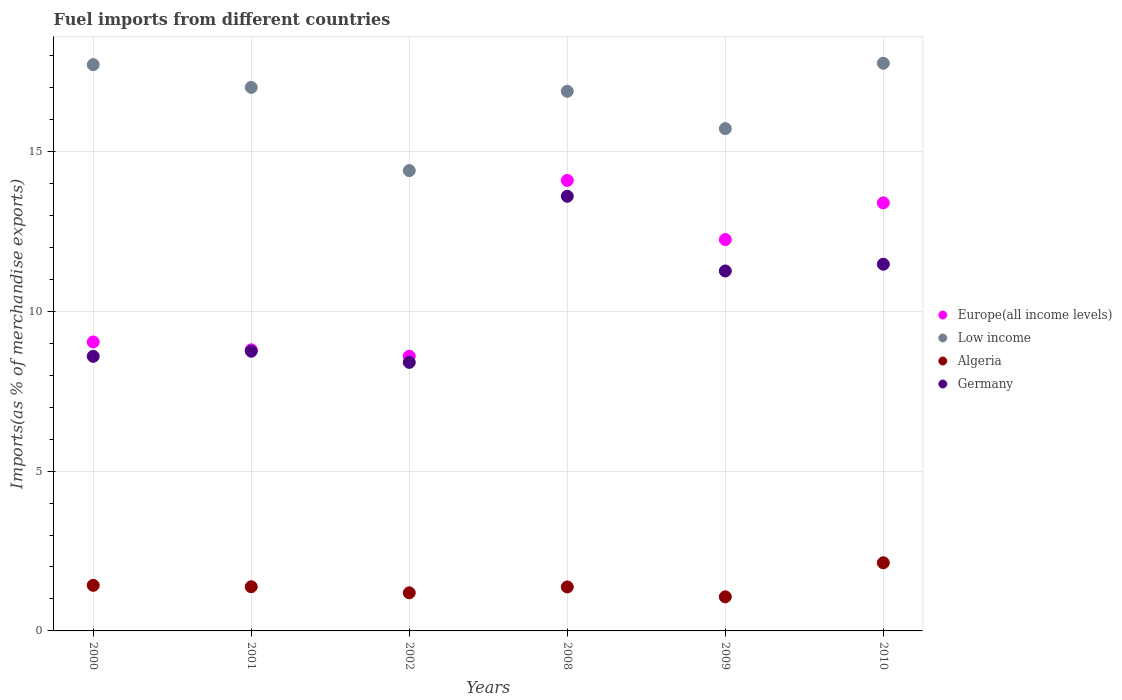Is the number of dotlines equal to the number of legend labels?
Your answer should be very brief. Yes. What is the percentage of imports to different countries in Germany in 2000?
Offer a very short reply. 8.59. Across all years, what is the maximum percentage of imports to different countries in Algeria?
Offer a very short reply. 2.13. Across all years, what is the minimum percentage of imports to different countries in Europe(all income levels)?
Give a very brief answer. 8.59. In which year was the percentage of imports to different countries in Germany minimum?
Offer a very short reply. 2002. What is the total percentage of imports to different countries in Algeria in the graph?
Provide a short and direct response. 8.58. What is the difference between the percentage of imports to different countries in Europe(all income levels) in 2008 and that in 2009?
Offer a terse response. 1.85. What is the difference between the percentage of imports to different countries in Low income in 2002 and the percentage of imports to different countries in Europe(all income levels) in 2009?
Give a very brief answer. 2.16. What is the average percentage of imports to different countries in Germany per year?
Ensure brevity in your answer.  10.35. In the year 2002, what is the difference between the percentage of imports to different countries in Algeria and percentage of imports to different countries in Low income?
Provide a succinct answer. -13.21. What is the ratio of the percentage of imports to different countries in Europe(all income levels) in 2009 to that in 2010?
Offer a very short reply. 0.91. What is the difference between the highest and the second highest percentage of imports to different countries in Low income?
Offer a terse response. 0.04. What is the difference between the highest and the lowest percentage of imports to different countries in Low income?
Make the answer very short. 3.36. In how many years, is the percentage of imports to different countries in Germany greater than the average percentage of imports to different countries in Germany taken over all years?
Provide a succinct answer. 3. Is it the case that in every year, the sum of the percentage of imports to different countries in Germany and percentage of imports to different countries in Algeria  is greater than the sum of percentage of imports to different countries in Low income and percentage of imports to different countries in Europe(all income levels)?
Ensure brevity in your answer.  No. Does the percentage of imports to different countries in Germany monotonically increase over the years?
Provide a short and direct response. No. Is the percentage of imports to different countries in Europe(all income levels) strictly less than the percentage of imports to different countries in Algeria over the years?
Your response must be concise. No. How many dotlines are there?
Keep it short and to the point. 4. What is the difference between two consecutive major ticks on the Y-axis?
Your answer should be compact. 5. Are the values on the major ticks of Y-axis written in scientific E-notation?
Your answer should be compact. No. Does the graph contain grids?
Keep it short and to the point. Yes. How many legend labels are there?
Keep it short and to the point. 4. How are the legend labels stacked?
Provide a short and direct response. Vertical. What is the title of the graph?
Keep it short and to the point. Fuel imports from different countries. What is the label or title of the Y-axis?
Make the answer very short. Imports(as % of merchandise exports). What is the Imports(as % of merchandise exports) of Europe(all income levels) in 2000?
Offer a terse response. 9.04. What is the Imports(as % of merchandise exports) of Low income in 2000?
Your answer should be very brief. 17.72. What is the Imports(as % of merchandise exports) of Algeria in 2000?
Keep it short and to the point. 1.43. What is the Imports(as % of merchandise exports) in Germany in 2000?
Your answer should be very brief. 8.59. What is the Imports(as % of merchandise exports) of Europe(all income levels) in 2001?
Your answer should be very brief. 8.8. What is the Imports(as % of merchandise exports) of Low income in 2001?
Your answer should be compact. 17.01. What is the Imports(as % of merchandise exports) of Algeria in 2001?
Ensure brevity in your answer.  1.38. What is the Imports(as % of merchandise exports) in Germany in 2001?
Make the answer very short. 8.75. What is the Imports(as % of merchandise exports) in Europe(all income levels) in 2002?
Provide a short and direct response. 8.59. What is the Imports(as % of merchandise exports) in Low income in 2002?
Give a very brief answer. 14.4. What is the Imports(as % of merchandise exports) in Algeria in 2002?
Your answer should be compact. 1.19. What is the Imports(as % of merchandise exports) of Germany in 2002?
Provide a succinct answer. 8.4. What is the Imports(as % of merchandise exports) in Europe(all income levels) in 2008?
Offer a very short reply. 14.09. What is the Imports(as % of merchandise exports) in Low income in 2008?
Keep it short and to the point. 16.88. What is the Imports(as % of merchandise exports) of Algeria in 2008?
Offer a very short reply. 1.38. What is the Imports(as % of merchandise exports) of Germany in 2008?
Give a very brief answer. 13.6. What is the Imports(as % of merchandise exports) in Europe(all income levels) in 2009?
Give a very brief answer. 12.24. What is the Imports(as % of merchandise exports) in Low income in 2009?
Offer a very short reply. 15.72. What is the Imports(as % of merchandise exports) of Algeria in 2009?
Your answer should be very brief. 1.07. What is the Imports(as % of merchandise exports) of Germany in 2009?
Provide a short and direct response. 11.26. What is the Imports(as % of merchandise exports) of Europe(all income levels) in 2010?
Give a very brief answer. 13.39. What is the Imports(as % of merchandise exports) of Low income in 2010?
Ensure brevity in your answer.  17.76. What is the Imports(as % of merchandise exports) of Algeria in 2010?
Your answer should be very brief. 2.13. What is the Imports(as % of merchandise exports) of Germany in 2010?
Give a very brief answer. 11.47. Across all years, what is the maximum Imports(as % of merchandise exports) of Europe(all income levels)?
Your response must be concise. 14.09. Across all years, what is the maximum Imports(as % of merchandise exports) of Low income?
Give a very brief answer. 17.76. Across all years, what is the maximum Imports(as % of merchandise exports) in Algeria?
Keep it short and to the point. 2.13. Across all years, what is the maximum Imports(as % of merchandise exports) of Germany?
Offer a very short reply. 13.6. Across all years, what is the minimum Imports(as % of merchandise exports) in Europe(all income levels)?
Your answer should be very brief. 8.59. Across all years, what is the minimum Imports(as % of merchandise exports) in Low income?
Ensure brevity in your answer.  14.4. Across all years, what is the minimum Imports(as % of merchandise exports) in Algeria?
Offer a very short reply. 1.07. Across all years, what is the minimum Imports(as % of merchandise exports) of Germany?
Make the answer very short. 8.4. What is the total Imports(as % of merchandise exports) in Europe(all income levels) in the graph?
Your answer should be compact. 66.16. What is the total Imports(as % of merchandise exports) of Low income in the graph?
Keep it short and to the point. 99.48. What is the total Imports(as % of merchandise exports) of Algeria in the graph?
Give a very brief answer. 8.58. What is the total Imports(as % of merchandise exports) of Germany in the graph?
Give a very brief answer. 62.08. What is the difference between the Imports(as % of merchandise exports) of Europe(all income levels) in 2000 and that in 2001?
Provide a short and direct response. 0.24. What is the difference between the Imports(as % of merchandise exports) of Low income in 2000 and that in 2001?
Give a very brief answer. 0.71. What is the difference between the Imports(as % of merchandise exports) of Algeria in 2000 and that in 2001?
Keep it short and to the point. 0.04. What is the difference between the Imports(as % of merchandise exports) in Germany in 2000 and that in 2001?
Offer a very short reply. -0.16. What is the difference between the Imports(as % of merchandise exports) of Europe(all income levels) in 2000 and that in 2002?
Give a very brief answer. 0.45. What is the difference between the Imports(as % of merchandise exports) of Low income in 2000 and that in 2002?
Offer a terse response. 3.31. What is the difference between the Imports(as % of merchandise exports) of Algeria in 2000 and that in 2002?
Offer a terse response. 0.23. What is the difference between the Imports(as % of merchandise exports) in Germany in 2000 and that in 2002?
Provide a succinct answer. 0.19. What is the difference between the Imports(as % of merchandise exports) of Europe(all income levels) in 2000 and that in 2008?
Keep it short and to the point. -5.05. What is the difference between the Imports(as % of merchandise exports) in Algeria in 2000 and that in 2008?
Make the answer very short. 0.05. What is the difference between the Imports(as % of merchandise exports) of Germany in 2000 and that in 2008?
Offer a terse response. -5.01. What is the difference between the Imports(as % of merchandise exports) of Europe(all income levels) in 2000 and that in 2009?
Make the answer very short. -3.2. What is the difference between the Imports(as % of merchandise exports) of Low income in 2000 and that in 2009?
Your answer should be compact. 2. What is the difference between the Imports(as % of merchandise exports) in Algeria in 2000 and that in 2009?
Provide a short and direct response. 0.36. What is the difference between the Imports(as % of merchandise exports) in Germany in 2000 and that in 2009?
Your answer should be compact. -2.67. What is the difference between the Imports(as % of merchandise exports) of Europe(all income levels) in 2000 and that in 2010?
Your answer should be very brief. -4.35. What is the difference between the Imports(as % of merchandise exports) of Low income in 2000 and that in 2010?
Provide a succinct answer. -0.04. What is the difference between the Imports(as % of merchandise exports) in Algeria in 2000 and that in 2010?
Give a very brief answer. -0.71. What is the difference between the Imports(as % of merchandise exports) in Germany in 2000 and that in 2010?
Make the answer very short. -2.88. What is the difference between the Imports(as % of merchandise exports) in Europe(all income levels) in 2001 and that in 2002?
Offer a very short reply. 0.2. What is the difference between the Imports(as % of merchandise exports) in Low income in 2001 and that in 2002?
Offer a very short reply. 2.6. What is the difference between the Imports(as % of merchandise exports) of Algeria in 2001 and that in 2002?
Offer a very short reply. 0.19. What is the difference between the Imports(as % of merchandise exports) in Germany in 2001 and that in 2002?
Give a very brief answer. 0.35. What is the difference between the Imports(as % of merchandise exports) of Europe(all income levels) in 2001 and that in 2008?
Provide a short and direct response. -5.3. What is the difference between the Imports(as % of merchandise exports) in Low income in 2001 and that in 2008?
Provide a short and direct response. 0.12. What is the difference between the Imports(as % of merchandise exports) in Algeria in 2001 and that in 2008?
Your answer should be very brief. 0.01. What is the difference between the Imports(as % of merchandise exports) of Germany in 2001 and that in 2008?
Provide a short and direct response. -4.85. What is the difference between the Imports(as % of merchandise exports) of Europe(all income levels) in 2001 and that in 2009?
Provide a short and direct response. -3.45. What is the difference between the Imports(as % of merchandise exports) in Low income in 2001 and that in 2009?
Give a very brief answer. 1.29. What is the difference between the Imports(as % of merchandise exports) of Algeria in 2001 and that in 2009?
Provide a succinct answer. 0.32. What is the difference between the Imports(as % of merchandise exports) in Germany in 2001 and that in 2009?
Offer a terse response. -2.51. What is the difference between the Imports(as % of merchandise exports) in Europe(all income levels) in 2001 and that in 2010?
Ensure brevity in your answer.  -4.6. What is the difference between the Imports(as % of merchandise exports) in Low income in 2001 and that in 2010?
Provide a short and direct response. -0.75. What is the difference between the Imports(as % of merchandise exports) in Algeria in 2001 and that in 2010?
Ensure brevity in your answer.  -0.75. What is the difference between the Imports(as % of merchandise exports) in Germany in 2001 and that in 2010?
Your answer should be compact. -2.72. What is the difference between the Imports(as % of merchandise exports) in Europe(all income levels) in 2002 and that in 2008?
Keep it short and to the point. -5.5. What is the difference between the Imports(as % of merchandise exports) in Low income in 2002 and that in 2008?
Ensure brevity in your answer.  -2.48. What is the difference between the Imports(as % of merchandise exports) of Algeria in 2002 and that in 2008?
Provide a succinct answer. -0.18. What is the difference between the Imports(as % of merchandise exports) of Germany in 2002 and that in 2008?
Provide a succinct answer. -5.2. What is the difference between the Imports(as % of merchandise exports) in Europe(all income levels) in 2002 and that in 2009?
Your answer should be very brief. -3.65. What is the difference between the Imports(as % of merchandise exports) of Low income in 2002 and that in 2009?
Give a very brief answer. -1.31. What is the difference between the Imports(as % of merchandise exports) in Algeria in 2002 and that in 2009?
Your response must be concise. 0.12. What is the difference between the Imports(as % of merchandise exports) in Germany in 2002 and that in 2009?
Ensure brevity in your answer.  -2.86. What is the difference between the Imports(as % of merchandise exports) in Europe(all income levels) in 2002 and that in 2010?
Provide a short and direct response. -4.8. What is the difference between the Imports(as % of merchandise exports) in Low income in 2002 and that in 2010?
Provide a short and direct response. -3.36. What is the difference between the Imports(as % of merchandise exports) of Algeria in 2002 and that in 2010?
Provide a short and direct response. -0.94. What is the difference between the Imports(as % of merchandise exports) of Germany in 2002 and that in 2010?
Give a very brief answer. -3.07. What is the difference between the Imports(as % of merchandise exports) of Europe(all income levels) in 2008 and that in 2009?
Offer a terse response. 1.85. What is the difference between the Imports(as % of merchandise exports) in Low income in 2008 and that in 2009?
Offer a terse response. 1.17. What is the difference between the Imports(as % of merchandise exports) of Algeria in 2008 and that in 2009?
Provide a succinct answer. 0.31. What is the difference between the Imports(as % of merchandise exports) in Germany in 2008 and that in 2009?
Provide a short and direct response. 2.34. What is the difference between the Imports(as % of merchandise exports) of Europe(all income levels) in 2008 and that in 2010?
Give a very brief answer. 0.7. What is the difference between the Imports(as % of merchandise exports) in Low income in 2008 and that in 2010?
Provide a short and direct response. -0.88. What is the difference between the Imports(as % of merchandise exports) in Algeria in 2008 and that in 2010?
Provide a short and direct response. -0.76. What is the difference between the Imports(as % of merchandise exports) of Germany in 2008 and that in 2010?
Your answer should be very brief. 2.13. What is the difference between the Imports(as % of merchandise exports) of Europe(all income levels) in 2009 and that in 2010?
Your answer should be very brief. -1.15. What is the difference between the Imports(as % of merchandise exports) of Low income in 2009 and that in 2010?
Your answer should be compact. -2.04. What is the difference between the Imports(as % of merchandise exports) in Algeria in 2009 and that in 2010?
Give a very brief answer. -1.06. What is the difference between the Imports(as % of merchandise exports) of Germany in 2009 and that in 2010?
Offer a very short reply. -0.21. What is the difference between the Imports(as % of merchandise exports) of Europe(all income levels) in 2000 and the Imports(as % of merchandise exports) of Low income in 2001?
Offer a very short reply. -7.97. What is the difference between the Imports(as % of merchandise exports) in Europe(all income levels) in 2000 and the Imports(as % of merchandise exports) in Algeria in 2001?
Keep it short and to the point. 7.66. What is the difference between the Imports(as % of merchandise exports) in Europe(all income levels) in 2000 and the Imports(as % of merchandise exports) in Germany in 2001?
Ensure brevity in your answer.  0.29. What is the difference between the Imports(as % of merchandise exports) of Low income in 2000 and the Imports(as % of merchandise exports) of Algeria in 2001?
Your answer should be compact. 16.33. What is the difference between the Imports(as % of merchandise exports) of Low income in 2000 and the Imports(as % of merchandise exports) of Germany in 2001?
Make the answer very short. 8.97. What is the difference between the Imports(as % of merchandise exports) in Algeria in 2000 and the Imports(as % of merchandise exports) in Germany in 2001?
Offer a very short reply. -7.32. What is the difference between the Imports(as % of merchandise exports) in Europe(all income levels) in 2000 and the Imports(as % of merchandise exports) in Low income in 2002?
Provide a short and direct response. -5.36. What is the difference between the Imports(as % of merchandise exports) in Europe(all income levels) in 2000 and the Imports(as % of merchandise exports) in Algeria in 2002?
Provide a succinct answer. 7.85. What is the difference between the Imports(as % of merchandise exports) of Europe(all income levels) in 2000 and the Imports(as % of merchandise exports) of Germany in 2002?
Provide a short and direct response. 0.64. What is the difference between the Imports(as % of merchandise exports) of Low income in 2000 and the Imports(as % of merchandise exports) of Algeria in 2002?
Keep it short and to the point. 16.52. What is the difference between the Imports(as % of merchandise exports) of Low income in 2000 and the Imports(as % of merchandise exports) of Germany in 2002?
Your response must be concise. 9.31. What is the difference between the Imports(as % of merchandise exports) of Algeria in 2000 and the Imports(as % of merchandise exports) of Germany in 2002?
Offer a very short reply. -6.97. What is the difference between the Imports(as % of merchandise exports) of Europe(all income levels) in 2000 and the Imports(as % of merchandise exports) of Low income in 2008?
Offer a terse response. -7.84. What is the difference between the Imports(as % of merchandise exports) in Europe(all income levels) in 2000 and the Imports(as % of merchandise exports) in Algeria in 2008?
Ensure brevity in your answer.  7.66. What is the difference between the Imports(as % of merchandise exports) of Europe(all income levels) in 2000 and the Imports(as % of merchandise exports) of Germany in 2008?
Offer a terse response. -4.56. What is the difference between the Imports(as % of merchandise exports) of Low income in 2000 and the Imports(as % of merchandise exports) of Algeria in 2008?
Offer a terse response. 16.34. What is the difference between the Imports(as % of merchandise exports) of Low income in 2000 and the Imports(as % of merchandise exports) of Germany in 2008?
Give a very brief answer. 4.12. What is the difference between the Imports(as % of merchandise exports) of Algeria in 2000 and the Imports(as % of merchandise exports) of Germany in 2008?
Offer a very short reply. -12.17. What is the difference between the Imports(as % of merchandise exports) of Europe(all income levels) in 2000 and the Imports(as % of merchandise exports) of Low income in 2009?
Keep it short and to the point. -6.68. What is the difference between the Imports(as % of merchandise exports) in Europe(all income levels) in 2000 and the Imports(as % of merchandise exports) in Algeria in 2009?
Your response must be concise. 7.97. What is the difference between the Imports(as % of merchandise exports) of Europe(all income levels) in 2000 and the Imports(as % of merchandise exports) of Germany in 2009?
Give a very brief answer. -2.22. What is the difference between the Imports(as % of merchandise exports) of Low income in 2000 and the Imports(as % of merchandise exports) of Algeria in 2009?
Provide a succinct answer. 16.65. What is the difference between the Imports(as % of merchandise exports) of Low income in 2000 and the Imports(as % of merchandise exports) of Germany in 2009?
Make the answer very short. 6.45. What is the difference between the Imports(as % of merchandise exports) of Algeria in 2000 and the Imports(as % of merchandise exports) of Germany in 2009?
Make the answer very short. -9.84. What is the difference between the Imports(as % of merchandise exports) in Europe(all income levels) in 2000 and the Imports(as % of merchandise exports) in Low income in 2010?
Your answer should be very brief. -8.72. What is the difference between the Imports(as % of merchandise exports) of Europe(all income levels) in 2000 and the Imports(as % of merchandise exports) of Algeria in 2010?
Provide a short and direct response. 6.91. What is the difference between the Imports(as % of merchandise exports) in Europe(all income levels) in 2000 and the Imports(as % of merchandise exports) in Germany in 2010?
Ensure brevity in your answer.  -2.43. What is the difference between the Imports(as % of merchandise exports) of Low income in 2000 and the Imports(as % of merchandise exports) of Algeria in 2010?
Your answer should be very brief. 15.58. What is the difference between the Imports(as % of merchandise exports) in Low income in 2000 and the Imports(as % of merchandise exports) in Germany in 2010?
Your answer should be very brief. 6.24. What is the difference between the Imports(as % of merchandise exports) of Algeria in 2000 and the Imports(as % of merchandise exports) of Germany in 2010?
Make the answer very short. -10.05. What is the difference between the Imports(as % of merchandise exports) in Europe(all income levels) in 2001 and the Imports(as % of merchandise exports) in Low income in 2002?
Your answer should be compact. -5.61. What is the difference between the Imports(as % of merchandise exports) in Europe(all income levels) in 2001 and the Imports(as % of merchandise exports) in Algeria in 2002?
Give a very brief answer. 7.6. What is the difference between the Imports(as % of merchandise exports) in Europe(all income levels) in 2001 and the Imports(as % of merchandise exports) in Germany in 2002?
Provide a short and direct response. 0.39. What is the difference between the Imports(as % of merchandise exports) of Low income in 2001 and the Imports(as % of merchandise exports) of Algeria in 2002?
Keep it short and to the point. 15.81. What is the difference between the Imports(as % of merchandise exports) of Low income in 2001 and the Imports(as % of merchandise exports) of Germany in 2002?
Offer a terse response. 8.6. What is the difference between the Imports(as % of merchandise exports) of Algeria in 2001 and the Imports(as % of merchandise exports) of Germany in 2002?
Give a very brief answer. -7.02. What is the difference between the Imports(as % of merchandise exports) of Europe(all income levels) in 2001 and the Imports(as % of merchandise exports) of Low income in 2008?
Make the answer very short. -8.09. What is the difference between the Imports(as % of merchandise exports) of Europe(all income levels) in 2001 and the Imports(as % of merchandise exports) of Algeria in 2008?
Keep it short and to the point. 7.42. What is the difference between the Imports(as % of merchandise exports) of Europe(all income levels) in 2001 and the Imports(as % of merchandise exports) of Germany in 2008?
Offer a very short reply. -4.8. What is the difference between the Imports(as % of merchandise exports) in Low income in 2001 and the Imports(as % of merchandise exports) in Algeria in 2008?
Provide a short and direct response. 15.63. What is the difference between the Imports(as % of merchandise exports) in Low income in 2001 and the Imports(as % of merchandise exports) in Germany in 2008?
Keep it short and to the point. 3.41. What is the difference between the Imports(as % of merchandise exports) in Algeria in 2001 and the Imports(as % of merchandise exports) in Germany in 2008?
Ensure brevity in your answer.  -12.22. What is the difference between the Imports(as % of merchandise exports) of Europe(all income levels) in 2001 and the Imports(as % of merchandise exports) of Low income in 2009?
Ensure brevity in your answer.  -6.92. What is the difference between the Imports(as % of merchandise exports) of Europe(all income levels) in 2001 and the Imports(as % of merchandise exports) of Algeria in 2009?
Give a very brief answer. 7.73. What is the difference between the Imports(as % of merchandise exports) in Europe(all income levels) in 2001 and the Imports(as % of merchandise exports) in Germany in 2009?
Provide a succinct answer. -2.47. What is the difference between the Imports(as % of merchandise exports) in Low income in 2001 and the Imports(as % of merchandise exports) in Algeria in 2009?
Ensure brevity in your answer.  15.94. What is the difference between the Imports(as % of merchandise exports) of Low income in 2001 and the Imports(as % of merchandise exports) of Germany in 2009?
Provide a succinct answer. 5.74. What is the difference between the Imports(as % of merchandise exports) of Algeria in 2001 and the Imports(as % of merchandise exports) of Germany in 2009?
Your answer should be very brief. -9.88. What is the difference between the Imports(as % of merchandise exports) in Europe(all income levels) in 2001 and the Imports(as % of merchandise exports) in Low income in 2010?
Keep it short and to the point. -8.96. What is the difference between the Imports(as % of merchandise exports) of Europe(all income levels) in 2001 and the Imports(as % of merchandise exports) of Algeria in 2010?
Provide a short and direct response. 6.66. What is the difference between the Imports(as % of merchandise exports) in Europe(all income levels) in 2001 and the Imports(as % of merchandise exports) in Germany in 2010?
Your answer should be very brief. -2.68. What is the difference between the Imports(as % of merchandise exports) of Low income in 2001 and the Imports(as % of merchandise exports) of Algeria in 2010?
Your answer should be very brief. 14.87. What is the difference between the Imports(as % of merchandise exports) in Low income in 2001 and the Imports(as % of merchandise exports) in Germany in 2010?
Keep it short and to the point. 5.53. What is the difference between the Imports(as % of merchandise exports) in Algeria in 2001 and the Imports(as % of merchandise exports) in Germany in 2010?
Your answer should be very brief. -10.09. What is the difference between the Imports(as % of merchandise exports) in Europe(all income levels) in 2002 and the Imports(as % of merchandise exports) in Low income in 2008?
Your answer should be compact. -8.29. What is the difference between the Imports(as % of merchandise exports) in Europe(all income levels) in 2002 and the Imports(as % of merchandise exports) in Algeria in 2008?
Give a very brief answer. 7.22. What is the difference between the Imports(as % of merchandise exports) of Europe(all income levels) in 2002 and the Imports(as % of merchandise exports) of Germany in 2008?
Give a very brief answer. -5. What is the difference between the Imports(as % of merchandise exports) of Low income in 2002 and the Imports(as % of merchandise exports) of Algeria in 2008?
Your answer should be compact. 13.03. What is the difference between the Imports(as % of merchandise exports) of Low income in 2002 and the Imports(as % of merchandise exports) of Germany in 2008?
Offer a terse response. 0.8. What is the difference between the Imports(as % of merchandise exports) of Algeria in 2002 and the Imports(as % of merchandise exports) of Germany in 2008?
Give a very brief answer. -12.41. What is the difference between the Imports(as % of merchandise exports) in Europe(all income levels) in 2002 and the Imports(as % of merchandise exports) in Low income in 2009?
Keep it short and to the point. -7.12. What is the difference between the Imports(as % of merchandise exports) in Europe(all income levels) in 2002 and the Imports(as % of merchandise exports) in Algeria in 2009?
Keep it short and to the point. 7.53. What is the difference between the Imports(as % of merchandise exports) of Europe(all income levels) in 2002 and the Imports(as % of merchandise exports) of Germany in 2009?
Provide a succinct answer. -2.67. What is the difference between the Imports(as % of merchandise exports) of Low income in 2002 and the Imports(as % of merchandise exports) of Algeria in 2009?
Keep it short and to the point. 13.33. What is the difference between the Imports(as % of merchandise exports) in Low income in 2002 and the Imports(as % of merchandise exports) in Germany in 2009?
Your answer should be compact. 3.14. What is the difference between the Imports(as % of merchandise exports) in Algeria in 2002 and the Imports(as % of merchandise exports) in Germany in 2009?
Your response must be concise. -10.07. What is the difference between the Imports(as % of merchandise exports) of Europe(all income levels) in 2002 and the Imports(as % of merchandise exports) of Low income in 2010?
Provide a short and direct response. -9.17. What is the difference between the Imports(as % of merchandise exports) in Europe(all income levels) in 2002 and the Imports(as % of merchandise exports) in Algeria in 2010?
Your answer should be very brief. 6.46. What is the difference between the Imports(as % of merchandise exports) of Europe(all income levels) in 2002 and the Imports(as % of merchandise exports) of Germany in 2010?
Keep it short and to the point. -2.88. What is the difference between the Imports(as % of merchandise exports) in Low income in 2002 and the Imports(as % of merchandise exports) in Algeria in 2010?
Give a very brief answer. 12.27. What is the difference between the Imports(as % of merchandise exports) in Low income in 2002 and the Imports(as % of merchandise exports) in Germany in 2010?
Your answer should be compact. 2.93. What is the difference between the Imports(as % of merchandise exports) of Algeria in 2002 and the Imports(as % of merchandise exports) of Germany in 2010?
Your answer should be very brief. -10.28. What is the difference between the Imports(as % of merchandise exports) in Europe(all income levels) in 2008 and the Imports(as % of merchandise exports) in Low income in 2009?
Provide a short and direct response. -1.62. What is the difference between the Imports(as % of merchandise exports) of Europe(all income levels) in 2008 and the Imports(as % of merchandise exports) of Algeria in 2009?
Your response must be concise. 13.03. What is the difference between the Imports(as % of merchandise exports) in Europe(all income levels) in 2008 and the Imports(as % of merchandise exports) in Germany in 2009?
Ensure brevity in your answer.  2.83. What is the difference between the Imports(as % of merchandise exports) in Low income in 2008 and the Imports(as % of merchandise exports) in Algeria in 2009?
Ensure brevity in your answer.  15.82. What is the difference between the Imports(as % of merchandise exports) in Low income in 2008 and the Imports(as % of merchandise exports) in Germany in 2009?
Ensure brevity in your answer.  5.62. What is the difference between the Imports(as % of merchandise exports) of Algeria in 2008 and the Imports(as % of merchandise exports) of Germany in 2009?
Your answer should be very brief. -9.89. What is the difference between the Imports(as % of merchandise exports) of Europe(all income levels) in 2008 and the Imports(as % of merchandise exports) of Low income in 2010?
Your answer should be very brief. -3.67. What is the difference between the Imports(as % of merchandise exports) of Europe(all income levels) in 2008 and the Imports(as % of merchandise exports) of Algeria in 2010?
Make the answer very short. 11.96. What is the difference between the Imports(as % of merchandise exports) in Europe(all income levels) in 2008 and the Imports(as % of merchandise exports) in Germany in 2010?
Your response must be concise. 2.62. What is the difference between the Imports(as % of merchandise exports) in Low income in 2008 and the Imports(as % of merchandise exports) in Algeria in 2010?
Your response must be concise. 14.75. What is the difference between the Imports(as % of merchandise exports) in Low income in 2008 and the Imports(as % of merchandise exports) in Germany in 2010?
Keep it short and to the point. 5.41. What is the difference between the Imports(as % of merchandise exports) of Algeria in 2008 and the Imports(as % of merchandise exports) of Germany in 2010?
Make the answer very short. -10.1. What is the difference between the Imports(as % of merchandise exports) of Europe(all income levels) in 2009 and the Imports(as % of merchandise exports) of Low income in 2010?
Ensure brevity in your answer.  -5.52. What is the difference between the Imports(as % of merchandise exports) in Europe(all income levels) in 2009 and the Imports(as % of merchandise exports) in Algeria in 2010?
Offer a very short reply. 10.11. What is the difference between the Imports(as % of merchandise exports) of Europe(all income levels) in 2009 and the Imports(as % of merchandise exports) of Germany in 2010?
Your response must be concise. 0.77. What is the difference between the Imports(as % of merchandise exports) of Low income in 2009 and the Imports(as % of merchandise exports) of Algeria in 2010?
Provide a succinct answer. 13.58. What is the difference between the Imports(as % of merchandise exports) in Low income in 2009 and the Imports(as % of merchandise exports) in Germany in 2010?
Offer a very short reply. 4.24. What is the difference between the Imports(as % of merchandise exports) of Algeria in 2009 and the Imports(as % of merchandise exports) of Germany in 2010?
Provide a succinct answer. -10.41. What is the average Imports(as % of merchandise exports) in Europe(all income levels) per year?
Provide a succinct answer. 11.03. What is the average Imports(as % of merchandise exports) in Low income per year?
Your response must be concise. 16.58. What is the average Imports(as % of merchandise exports) of Algeria per year?
Offer a very short reply. 1.43. What is the average Imports(as % of merchandise exports) of Germany per year?
Keep it short and to the point. 10.35. In the year 2000, what is the difference between the Imports(as % of merchandise exports) of Europe(all income levels) and Imports(as % of merchandise exports) of Low income?
Your answer should be compact. -8.68. In the year 2000, what is the difference between the Imports(as % of merchandise exports) in Europe(all income levels) and Imports(as % of merchandise exports) in Algeria?
Provide a succinct answer. 7.61. In the year 2000, what is the difference between the Imports(as % of merchandise exports) of Europe(all income levels) and Imports(as % of merchandise exports) of Germany?
Ensure brevity in your answer.  0.45. In the year 2000, what is the difference between the Imports(as % of merchandise exports) of Low income and Imports(as % of merchandise exports) of Algeria?
Provide a short and direct response. 16.29. In the year 2000, what is the difference between the Imports(as % of merchandise exports) in Low income and Imports(as % of merchandise exports) in Germany?
Your response must be concise. 9.13. In the year 2000, what is the difference between the Imports(as % of merchandise exports) in Algeria and Imports(as % of merchandise exports) in Germany?
Your answer should be very brief. -7.16. In the year 2001, what is the difference between the Imports(as % of merchandise exports) of Europe(all income levels) and Imports(as % of merchandise exports) of Low income?
Offer a terse response. -8.21. In the year 2001, what is the difference between the Imports(as % of merchandise exports) in Europe(all income levels) and Imports(as % of merchandise exports) in Algeria?
Provide a short and direct response. 7.41. In the year 2001, what is the difference between the Imports(as % of merchandise exports) of Europe(all income levels) and Imports(as % of merchandise exports) of Germany?
Your response must be concise. 0.05. In the year 2001, what is the difference between the Imports(as % of merchandise exports) in Low income and Imports(as % of merchandise exports) in Algeria?
Give a very brief answer. 15.62. In the year 2001, what is the difference between the Imports(as % of merchandise exports) of Low income and Imports(as % of merchandise exports) of Germany?
Give a very brief answer. 8.26. In the year 2001, what is the difference between the Imports(as % of merchandise exports) in Algeria and Imports(as % of merchandise exports) in Germany?
Provide a succinct answer. -7.37. In the year 2002, what is the difference between the Imports(as % of merchandise exports) of Europe(all income levels) and Imports(as % of merchandise exports) of Low income?
Offer a terse response. -5.81. In the year 2002, what is the difference between the Imports(as % of merchandise exports) of Europe(all income levels) and Imports(as % of merchandise exports) of Algeria?
Provide a succinct answer. 7.4. In the year 2002, what is the difference between the Imports(as % of merchandise exports) in Europe(all income levels) and Imports(as % of merchandise exports) in Germany?
Keep it short and to the point. 0.19. In the year 2002, what is the difference between the Imports(as % of merchandise exports) of Low income and Imports(as % of merchandise exports) of Algeria?
Make the answer very short. 13.21. In the year 2002, what is the difference between the Imports(as % of merchandise exports) of Low income and Imports(as % of merchandise exports) of Germany?
Keep it short and to the point. 6. In the year 2002, what is the difference between the Imports(as % of merchandise exports) of Algeria and Imports(as % of merchandise exports) of Germany?
Keep it short and to the point. -7.21. In the year 2008, what is the difference between the Imports(as % of merchandise exports) in Europe(all income levels) and Imports(as % of merchandise exports) in Low income?
Offer a very short reply. -2.79. In the year 2008, what is the difference between the Imports(as % of merchandise exports) in Europe(all income levels) and Imports(as % of merchandise exports) in Algeria?
Your answer should be compact. 12.72. In the year 2008, what is the difference between the Imports(as % of merchandise exports) in Europe(all income levels) and Imports(as % of merchandise exports) in Germany?
Provide a succinct answer. 0.49. In the year 2008, what is the difference between the Imports(as % of merchandise exports) of Low income and Imports(as % of merchandise exports) of Algeria?
Ensure brevity in your answer.  15.51. In the year 2008, what is the difference between the Imports(as % of merchandise exports) in Low income and Imports(as % of merchandise exports) in Germany?
Your answer should be very brief. 3.28. In the year 2008, what is the difference between the Imports(as % of merchandise exports) in Algeria and Imports(as % of merchandise exports) in Germany?
Offer a very short reply. -12.22. In the year 2009, what is the difference between the Imports(as % of merchandise exports) of Europe(all income levels) and Imports(as % of merchandise exports) of Low income?
Offer a terse response. -3.47. In the year 2009, what is the difference between the Imports(as % of merchandise exports) in Europe(all income levels) and Imports(as % of merchandise exports) in Algeria?
Give a very brief answer. 11.18. In the year 2009, what is the difference between the Imports(as % of merchandise exports) in Europe(all income levels) and Imports(as % of merchandise exports) in Germany?
Offer a very short reply. 0.98. In the year 2009, what is the difference between the Imports(as % of merchandise exports) in Low income and Imports(as % of merchandise exports) in Algeria?
Your answer should be very brief. 14.65. In the year 2009, what is the difference between the Imports(as % of merchandise exports) of Low income and Imports(as % of merchandise exports) of Germany?
Offer a terse response. 4.45. In the year 2009, what is the difference between the Imports(as % of merchandise exports) in Algeria and Imports(as % of merchandise exports) in Germany?
Your answer should be very brief. -10.2. In the year 2010, what is the difference between the Imports(as % of merchandise exports) of Europe(all income levels) and Imports(as % of merchandise exports) of Low income?
Make the answer very short. -4.37. In the year 2010, what is the difference between the Imports(as % of merchandise exports) of Europe(all income levels) and Imports(as % of merchandise exports) of Algeria?
Offer a very short reply. 11.26. In the year 2010, what is the difference between the Imports(as % of merchandise exports) in Europe(all income levels) and Imports(as % of merchandise exports) in Germany?
Make the answer very short. 1.92. In the year 2010, what is the difference between the Imports(as % of merchandise exports) of Low income and Imports(as % of merchandise exports) of Algeria?
Keep it short and to the point. 15.63. In the year 2010, what is the difference between the Imports(as % of merchandise exports) of Low income and Imports(as % of merchandise exports) of Germany?
Provide a succinct answer. 6.29. In the year 2010, what is the difference between the Imports(as % of merchandise exports) of Algeria and Imports(as % of merchandise exports) of Germany?
Give a very brief answer. -9.34. What is the ratio of the Imports(as % of merchandise exports) in Europe(all income levels) in 2000 to that in 2001?
Give a very brief answer. 1.03. What is the ratio of the Imports(as % of merchandise exports) in Low income in 2000 to that in 2001?
Ensure brevity in your answer.  1.04. What is the ratio of the Imports(as % of merchandise exports) of Algeria in 2000 to that in 2001?
Provide a short and direct response. 1.03. What is the ratio of the Imports(as % of merchandise exports) of Germany in 2000 to that in 2001?
Give a very brief answer. 0.98. What is the ratio of the Imports(as % of merchandise exports) in Europe(all income levels) in 2000 to that in 2002?
Keep it short and to the point. 1.05. What is the ratio of the Imports(as % of merchandise exports) in Low income in 2000 to that in 2002?
Ensure brevity in your answer.  1.23. What is the ratio of the Imports(as % of merchandise exports) in Algeria in 2000 to that in 2002?
Give a very brief answer. 1.2. What is the ratio of the Imports(as % of merchandise exports) in Germany in 2000 to that in 2002?
Provide a short and direct response. 1.02. What is the ratio of the Imports(as % of merchandise exports) in Europe(all income levels) in 2000 to that in 2008?
Your answer should be compact. 0.64. What is the ratio of the Imports(as % of merchandise exports) in Low income in 2000 to that in 2008?
Keep it short and to the point. 1.05. What is the ratio of the Imports(as % of merchandise exports) of Algeria in 2000 to that in 2008?
Keep it short and to the point. 1.04. What is the ratio of the Imports(as % of merchandise exports) of Germany in 2000 to that in 2008?
Offer a very short reply. 0.63. What is the ratio of the Imports(as % of merchandise exports) in Europe(all income levels) in 2000 to that in 2009?
Keep it short and to the point. 0.74. What is the ratio of the Imports(as % of merchandise exports) of Low income in 2000 to that in 2009?
Offer a very short reply. 1.13. What is the ratio of the Imports(as % of merchandise exports) of Algeria in 2000 to that in 2009?
Provide a short and direct response. 1.34. What is the ratio of the Imports(as % of merchandise exports) in Germany in 2000 to that in 2009?
Ensure brevity in your answer.  0.76. What is the ratio of the Imports(as % of merchandise exports) in Europe(all income levels) in 2000 to that in 2010?
Keep it short and to the point. 0.68. What is the ratio of the Imports(as % of merchandise exports) of Low income in 2000 to that in 2010?
Your response must be concise. 1. What is the ratio of the Imports(as % of merchandise exports) in Algeria in 2000 to that in 2010?
Your answer should be compact. 0.67. What is the ratio of the Imports(as % of merchandise exports) of Germany in 2000 to that in 2010?
Your answer should be very brief. 0.75. What is the ratio of the Imports(as % of merchandise exports) of Europe(all income levels) in 2001 to that in 2002?
Keep it short and to the point. 1.02. What is the ratio of the Imports(as % of merchandise exports) of Low income in 2001 to that in 2002?
Make the answer very short. 1.18. What is the ratio of the Imports(as % of merchandise exports) of Algeria in 2001 to that in 2002?
Provide a succinct answer. 1.16. What is the ratio of the Imports(as % of merchandise exports) of Germany in 2001 to that in 2002?
Ensure brevity in your answer.  1.04. What is the ratio of the Imports(as % of merchandise exports) in Europe(all income levels) in 2001 to that in 2008?
Offer a very short reply. 0.62. What is the ratio of the Imports(as % of merchandise exports) in Low income in 2001 to that in 2008?
Keep it short and to the point. 1.01. What is the ratio of the Imports(as % of merchandise exports) of Germany in 2001 to that in 2008?
Your response must be concise. 0.64. What is the ratio of the Imports(as % of merchandise exports) of Europe(all income levels) in 2001 to that in 2009?
Offer a terse response. 0.72. What is the ratio of the Imports(as % of merchandise exports) of Low income in 2001 to that in 2009?
Ensure brevity in your answer.  1.08. What is the ratio of the Imports(as % of merchandise exports) of Algeria in 2001 to that in 2009?
Offer a terse response. 1.3. What is the ratio of the Imports(as % of merchandise exports) in Germany in 2001 to that in 2009?
Make the answer very short. 0.78. What is the ratio of the Imports(as % of merchandise exports) of Europe(all income levels) in 2001 to that in 2010?
Your response must be concise. 0.66. What is the ratio of the Imports(as % of merchandise exports) of Low income in 2001 to that in 2010?
Your answer should be very brief. 0.96. What is the ratio of the Imports(as % of merchandise exports) of Algeria in 2001 to that in 2010?
Offer a terse response. 0.65. What is the ratio of the Imports(as % of merchandise exports) of Germany in 2001 to that in 2010?
Offer a very short reply. 0.76. What is the ratio of the Imports(as % of merchandise exports) in Europe(all income levels) in 2002 to that in 2008?
Offer a very short reply. 0.61. What is the ratio of the Imports(as % of merchandise exports) in Low income in 2002 to that in 2008?
Your answer should be very brief. 0.85. What is the ratio of the Imports(as % of merchandise exports) of Algeria in 2002 to that in 2008?
Ensure brevity in your answer.  0.87. What is the ratio of the Imports(as % of merchandise exports) of Germany in 2002 to that in 2008?
Keep it short and to the point. 0.62. What is the ratio of the Imports(as % of merchandise exports) of Europe(all income levels) in 2002 to that in 2009?
Keep it short and to the point. 0.7. What is the ratio of the Imports(as % of merchandise exports) in Low income in 2002 to that in 2009?
Your answer should be very brief. 0.92. What is the ratio of the Imports(as % of merchandise exports) in Algeria in 2002 to that in 2009?
Your response must be concise. 1.12. What is the ratio of the Imports(as % of merchandise exports) of Germany in 2002 to that in 2009?
Provide a short and direct response. 0.75. What is the ratio of the Imports(as % of merchandise exports) in Europe(all income levels) in 2002 to that in 2010?
Your response must be concise. 0.64. What is the ratio of the Imports(as % of merchandise exports) in Low income in 2002 to that in 2010?
Offer a terse response. 0.81. What is the ratio of the Imports(as % of merchandise exports) in Algeria in 2002 to that in 2010?
Keep it short and to the point. 0.56. What is the ratio of the Imports(as % of merchandise exports) in Germany in 2002 to that in 2010?
Offer a terse response. 0.73. What is the ratio of the Imports(as % of merchandise exports) in Europe(all income levels) in 2008 to that in 2009?
Provide a short and direct response. 1.15. What is the ratio of the Imports(as % of merchandise exports) in Low income in 2008 to that in 2009?
Provide a succinct answer. 1.07. What is the ratio of the Imports(as % of merchandise exports) of Algeria in 2008 to that in 2009?
Give a very brief answer. 1.29. What is the ratio of the Imports(as % of merchandise exports) of Germany in 2008 to that in 2009?
Offer a very short reply. 1.21. What is the ratio of the Imports(as % of merchandise exports) in Europe(all income levels) in 2008 to that in 2010?
Provide a short and direct response. 1.05. What is the ratio of the Imports(as % of merchandise exports) of Low income in 2008 to that in 2010?
Provide a short and direct response. 0.95. What is the ratio of the Imports(as % of merchandise exports) in Algeria in 2008 to that in 2010?
Give a very brief answer. 0.65. What is the ratio of the Imports(as % of merchandise exports) of Germany in 2008 to that in 2010?
Give a very brief answer. 1.19. What is the ratio of the Imports(as % of merchandise exports) of Europe(all income levels) in 2009 to that in 2010?
Make the answer very short. 0.91. What is the ratio of the Imports(as % of merchandise exports) of Low income in 2009 to that in 2010?
Make the answer very short. 0.88. What is the ratio of the Imports(as % of merchandise exports) in Algeria in 2009 to that in 2010?
Offer a terse response. 0.5. What is the ratio of the Imports(as % of merchandise exports) of Germany in 2009 to that in 2010?
Make the answer very short. 0.98. What is the difference between the highest and the second highest Imports(as % of merchandise exports) of Europe(all income levels)?
Make the answer very short. 0.7. What is the difference between the highest and the second highest Imports(as % of merchandise exports) of Low income?
Your response must be concise. 0.04. What is the difference between the highest and the second highest Imports(as % of merchandise exports) in Algeria?
Your response must be concise. 0.71. What is the difference between the highest and the second highest Imports(as % of merchandise exports) in Germany?
Make the answer very short. 2.13. What is the difference between the highest and the lowest Imports(as % of merchandise exports) in Europe(all income levels)?
Offer a very short reply. 5.5. What is the difference between the highest and the lowest Imports(as % of merchandise exports) of Low income?
Offer a very short reply. 3.36. What is the difference between the highest and the lowest Imports(as % of merchandise exports) in Algeria?
Provide a short and direct response. 1.06. What is the difference between the highest and the lowest Imports(as % of merchandise exports) of Germany?
Your answer should be compact. 5.2. 